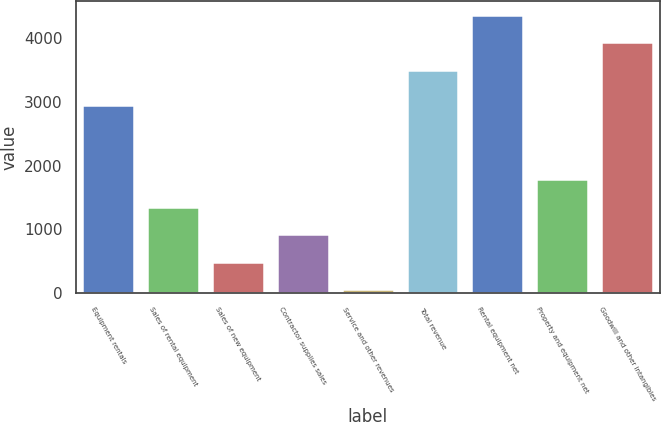<chart> <loc_0><loc_0><loc_500><loc_500><bar_chart><fcel>Equipment rentals<fcel>Sales of rental equipment<fcel>Sales of new equipment<fcel>Contractor supplies sales<fcel>Service and other revenues<fcel>Total revenue<fcel>Rental equipment net<fcel>Property and equipment net<fcel>Goodwill and other intangibles<nl><fcel>2948<fcel>1353.3<fcel>495.1<fcel>924.2<fcel>66<fcel>3498<fcel>4357<fcel>1782.4<fcel>3927.1<nl></chart> 